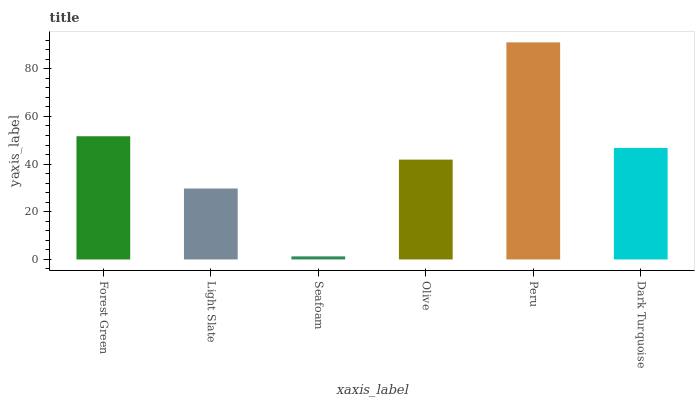Is Seafoam the minimum?
Answer yes or no. Yes. Is Peru the maximum?
Answer yes or no. Yes. Is Light Slate the minimum?
Answer yes or no. No. Is Light Slate the maximum?
Answer yes or no. No. Is Forest Green greater than Light Slate?
Answer yes or no. Yes. Is Light Slate less than Forest Green?
Answer yes or no. Yes. Is Light Slate greater than Forest Green?
Answer yes or no. No. Is Forest Green less than Light Slate?
Answer yes or no. No. Is Dark Turquoise the high median?
Answer yes or no. Yes. Is Olive the low median?
Answer yes or no. Yes. Is Seafoam the high median?
Answer yes or no. No. Is Peru the low median?
Answer yes or no. No. 